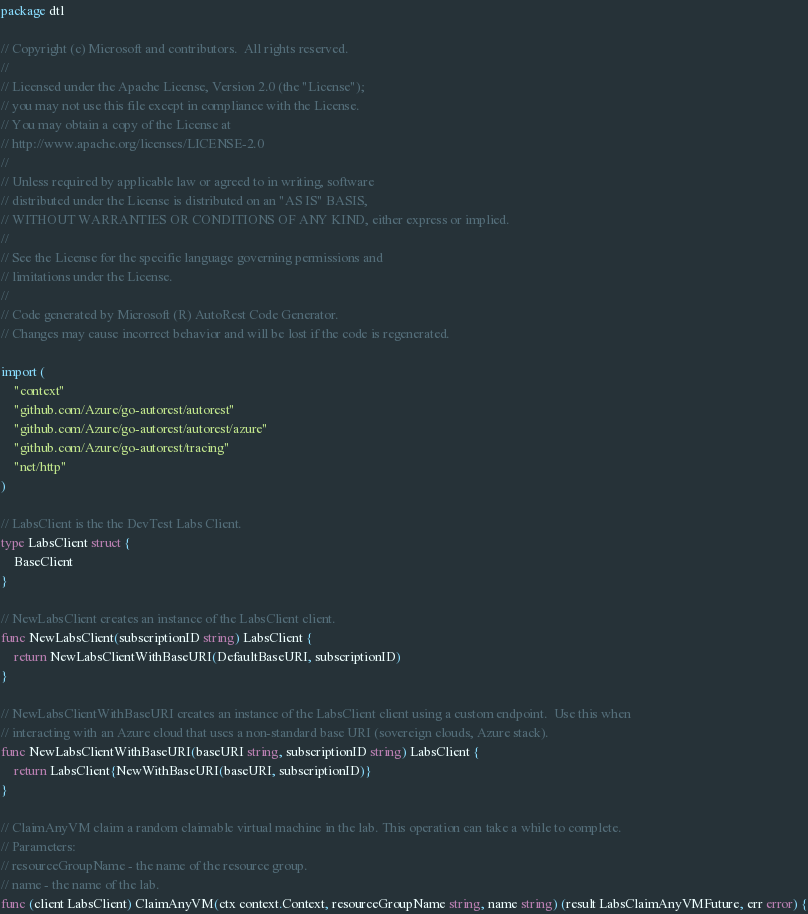Convert code to text. <code><loc_0><loc_0><loc_500><loc_500><_Go_>package dtl

// Copyright (c) Microsoft and contributors.  All rights reserved.
//
// Licensed under the Apache License, Version 2.0 (the "License");
// you may not use this file except in compliance with the License.
// You may obtain a copy of the License at
// http://www.apache.org/licenses/LICENSE-2.0
//
// Unless required by applicable law or agreed to in writing, software
// distributed under the License is distributed on an "AS IS" BASIS,
// WITHOUT WARRANTIES OR CONDITIONS OF ANY KIND, either express or implied.
//
// See the License for the specific language governing permissions and
// limitations under the License.
//
// Code generated by Microsoft (R) AutoRest Code Generator.
// Changes may cause incorrect behavior and will be lost if the code is regenerated.

import (
	"context"
	"github.com/Azure/go-autorest/autorest"
	"github.com/Azure/go-autorest/autorest/azure"
	"github.com/Azure/go-autorest/tracing"
	"net/http"
)

// LabsClient is the the DevTest Labs Client.
type LabsClient struct {
	BaseClient
}

// NewLabsClient creates an instance of the LabsClient client.
func NewLabsClient(subscriptionID string) LabsClient {
	return NewLabsClientWithBaseURI(DefaultBaseURI, subscriptionID)
}

// NewLabsClientWithBaseURI creates an instance of the LabsClient client using a custom endpoint.  Use this when
// interacting with an Azure cloud that uses a non-standard base URI (sovereign clouds, Azure stack).
func NewLabsClientWithBaseURI(baseURI string, subscriptionID string) LabsClient {
	return LabsClient{NewWithBaseURI(baseURI, subscriptionID)}
}

// ClaimAnyVM claim a random claimable virtual machine in the lab. This operation can take a while to complete.
// Parameters:
// resourceGroupName - the name of the resource group.
// name - the name of the lab.
func (client LabsClient) ClaimAnyVM(ctx context.Context, resourceGroupName string, name string) (result LabsClaimAnyVMFuture, err error) {</code> 